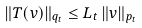<formula> <loc_0><loc_0><loc_500><loc_500>\| T ( v ) \| _ { q _ { t } } \leq L _ { t } \, \| v \| _ { p _ { t } }</formula> 